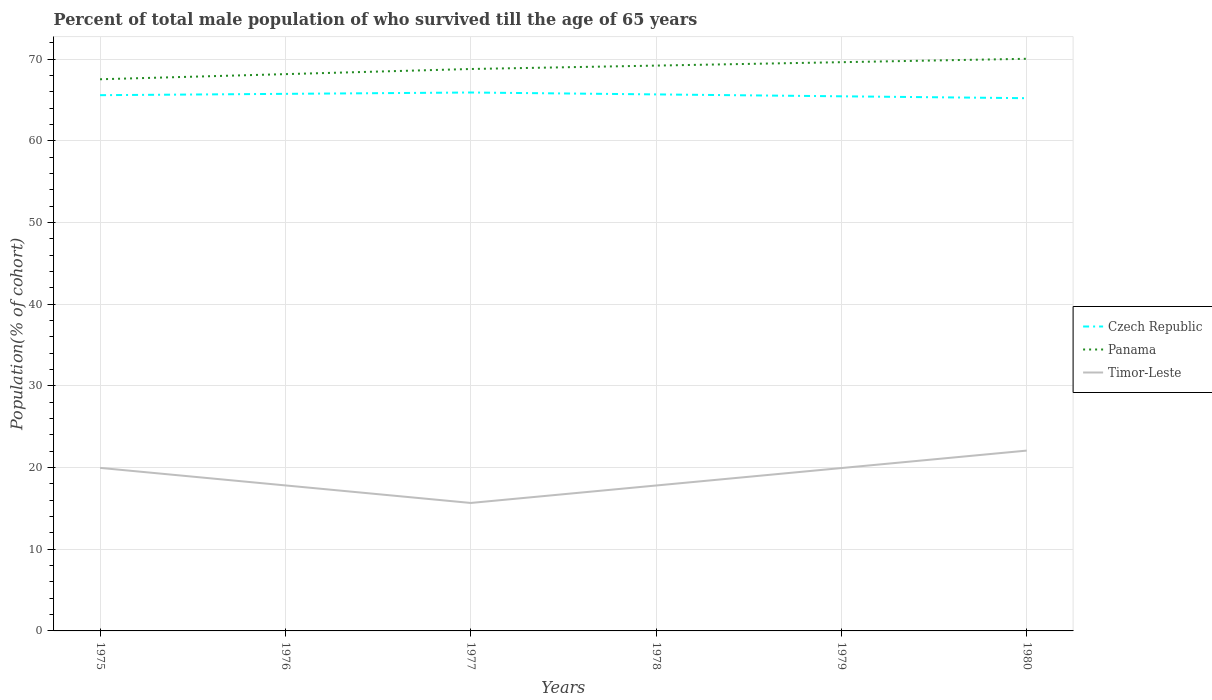How many different coloured lines are there?
Provide a succinct answer. 3. Does the line corresponding to Czech Republic intersect with the line corresponding to Panama?
Make the answer very short. No. Is the number of lines equal to the number of legend labels?
Offer a very short reply. Yes. Across all years, what is the maximum percentage of total male population who survived till the age of 65 years in Panama?
Ensure brevity in your answer.  67.56. In which year was the percentage of total male population who survived till the age of 65 years in Czech Republic maximum?
Keep it short and to the point. 1980. What is the total percentage of total male population who survived till the age of 65 years in Panama in the graph?
Your answer should be compact. -0.63. What is the difference between the highest and the second highest percentage of total male population who survived till the age of 65 years in Panama?
Provide a short and direct response. 2.51. What is the difference between the highest and the lowest percentage of total male population who survived till the age of 65 years in Panama?
Offer a very short reply. 3. Is the percentage of total male population who survived till the age of 65 years in Czech Republic strictly greater than the percentage of total male population who survived till the age of 65 years in Timor-Leste over the years?
Offer a very short reply. No. How many lines are there?
Your response must be concise. 3. How many years are there in the graph?
Ensure brevity in your answer.  6. What is the difference between two consecutive major ticks on the Y-axis?
Give a very brief answer. 10. Are the values on the major ticks of Y-axis written in scientific E-notation?
Make the answer very short. No. What is the title of the graph?
Offer a very short reply. Percent of total male population of who survived till the age of 65 years. What is the label or title of the X-axis?
Provide a short and direct response. Years. What is the label or title of the Y-axis?
Your response must be concise. Population(% of cohort). What is the Population(% of cohort) in Czech Republic in 1975?
Your response must be concise. 65.61. What is the Population(% of cohort) of Panama in 1975?
Offer a terse response. 67.56. What is the Population(% of cohort) in Timor-Leste in 1975?
Offer a very short reply. 19.97. What is the Population(% of cohort) in Czech Republic in 1976?
Provide a succinct answer. 65.77. What is the Population(% of cohort) in Panama in 1976?
Offer a terse response. 68.18. What is the Population(% of cohort) in Timor-Leste in 1976?
Offer a very short reply. 17.82. What is the Population(% of cohort) of Czech Republic in 1977?
Offer a terse response. 65.93. What is the Population(% of cohort) in Panama in 1977?
Your response must be concise. 68.81. What is the Population(% of cohort) in Timor-Leste in 1977?
Give a very brief answer. 15.67. What is the Population(% of cohort) in Czech Republic in 1978?
Your answer should be very brief. 65.7. What is the Population(% of cohort) of Panama in 1978?
Make the answer very short. 69.23. What is the Population(% of cohort) in Timor-Leste in 1978?
Ensure brevity in your answer.  17.81. What is the Population(% of cohort) of Czech Republic in 1979?
Provide a succinct answer. 65.47. What is the Population(% of cohort) of Panama in 1979?
Your response must be concise. 69.65. What is the Population(% of cohort) in Timor-Leste in 1979?
Your answer should be compact. 19.95. What is the Population(% of cohort) of Czech Republic in 1980?
Make the answer very short. 65.24. What is the Population(% of cohort) in Panama in 1980?
Your answer should be compact. 70.06. What is the Population(% of cohort) in Timor-Leste in 1980?
Make the answer very short. 22.08. Across all years, what is the maximum Population(% of cohort) of Czech Republic?
Your answer should be compact. 65.93. Across all years, what is the maximum Population(% of cohort) of Panama?
Your answer should be very brief. 70.06. Across all years, what is the maximum Population(% of cohort) of Timor-Leste?
Your response must be concise. 22.08. Across all years, what is the minimum Population(% of cohort) in Czech Republic?
Your answer should be compact. 65.24. Across all years, what is the minimum Population(% of cohort) of Panama?
Your response must be concise. 67.56. Across all years, what is the minimum Population(% of cohort) of Timor-Leste?
Keep it short and to the point. 15.67. What is the total Population(% of cohort) of Czech Republic in the graph?
Make the answer very short. 393.72. What is the total Population(% of cohort) of Panama in the graph?
Give a very brief answer. 413.49. What is the total Population(% of cohort) of Timor-Leste in the graph?
Give a very brief answer. 113.29. What is the difference between the Population(% of cohort) of Czech Republic in 1975 and that in 1976?
Ensure brevity in your answer.  -0.16. What is the difference between the Population(% of cohort) of Panama in 1975 and that in 1976?
Your answer should be very brief. -0.63. What is the difference between the Population(% of cohort) in Timor-Leste in 1975 and that in 1976?
Offer a terse response. 2.15. What is the difference between the Population(% of cohort) in Czech Republic in 1975 and that in 1977?
Keep it short and to the point. -0.33. What is the difference between the Population(% of cohort) in Panama in 1975 and that in 1977?
Offer a terse response. -1.26. What is the difference between the Population(% of cohort) in Timor-Leste in 1975 and that in 1977?
Give a very brief answer. 4.29. What is the difference between the Population(% of cohort) of Czech Republic in 1975 and that in 1978?
Offer a terse response. -0.1. What is the difference between the Population(% of cohort) in Panama in 1975 and that in 1978?
Provide a short and direct response. -1.67. What is the difference between the Population(% of cohort) of Timor-Leste in 1975 and that in 1978?
Your answer should be very brief. 2.16. What is the difference between the Population(% of cohort) in Czech Republic in 1975 and that in 1979?
Offer a very short reply. 0.14. What is the difference between the Population(% of cohort) of Panama in 1975 and that in 1979?
Offer a terse response. -2.09. What is the difference between the Population(% of cohort) of Timor-Leste in 1975 and that in 1979?
Provide a short and direct response. 0.02. What is the difference between the Population(% of cohort) of Czech Republic in 1975 and that in 1980?
Offer a very short reply. 0.37. What is the difference between the Population(% of cohort) of Panama in 1975 and that in 1980?
Keep it short and to the point. -2.51. What is the difference between the Population(% of cohort) in Timor-Leste in 1975 and that in 1980?
Provide a succinct answer. -2.12. What is the difference between the Population(% of cohort) of Czech Republic in 1976 and that in 1977?
Your answer should be very brief. -0.16. What is the difference between the Population(% of cohort) in Panama in 1976 and that in 1977?
Give a very brief answer. -0.63. What is the difference between the Population(% of cohort) in Timor-Leste in 1976 and that in 1977?
Offer a terse response. 2.15. What is the difference between the Population(% of cohort) of Czech Republic in 1976 and that in 1978?
Your response must be concise. 0.07. What is the difference between the Population(% of cohort) in Panama in 1976 and that in 1978?
Provide a succinct answer. -1.05. What is the difference between the Population(% of cohort) in Timor-Leste in 1976 and that in 1978?
Give a very brief answer. 0.01. What is the difference between the Population(% of cohort) in Czech Republic in 1976 and that in 1979?
Ensure brevity in your answer.  0.3. What is the difference between the Population(% of cohort) in Panama in 1976 and that in 1979?
Give a very brief answer. -1.46. What is the difference between the Population(% of cohort) in Timor-Leste in 1976 and that in 1979?
Keep it short and to the point. -2.13. What is the difference between the Population(% of cohort) of Czech Republic in 1976 and that in 1980?
Offer a very short reply. 0.53. What is the difference between the Population(% of cohort) of Panama in 1976 and that in 1980?
Keep it short and to the point. -1.88. What is the difference between the Population(% of cohort) in Timor-Leste in 1976 and that in 1980?
Make the answer very short. -4.26. What is the difference between the Population(% of cohort) of Czech Republic in 1977 and that in 1978?
Your response must be concise. 0.23. What is the difference between the Population(% of cohort) of Panama in 1977 and that in 1978?
Offer a terse response. -0.42. What is the difference between the Population(% of cohort) in Timor-Leste in 1977 and that in 1978?
Your response must be concise. -2.14. What is the difference between the Population(% of cohort) of Czech Republic in 1977 and that in 1979?
Ensure brevity in your answer.  0.46. What is the difference between the Population(% of cohort) in Panama in 1977 and that in 1979?
Offer a terse response. -0.83. What is the difference between the Population(% of cohort) in Timor-Leste in 1977 and that in 1979?
Your response must be concise. -4.27. What is the difference between the Population(% of cohort) in Czech Republic in 1977 and that in 1980?
Provide a succinct answer. 0.7. What is the difference between the Population(% of cohort) of Panama in 1977 and that in 1980?
Offer a terse response. -1.25. What is the difference between the Population(% of cohort) of Timor-Leste in 1977 and that in 1980?
Ensure brevity in your answer.  -6.41. What is the difference between the Population(% of cohort) in Czech Republic in 1978 and that in 1979?
Your response must be concise. 0.23. What is the difference between the Population(% of cohort) in Panama in 1978 and that in 1979?
Provide a short and direct response. -0.42. What is the difference between the Population(% of cohort) in Timor-Leste in 1978 and that in 1979?
Offer a very short reply. -2.14. What is the difference between the Population(% of cohort) of Czech Republic in 1978 and that in 1980?
Offer a terse response. 0.46. What is the difference between the Population(% of cohort) of Panama in 1978 and that in 1980?
Make the answer very short. -0.83. What is the difference between the Population(% of cohort) in Timor-Leste in 1978 and that in 1980?
Provide a short and direct response. -4.27. What is the difference between the Population(% of cohort) of Czech Republic in 1979 and that in 1980?
Ensure brevity in your answer.  0.23. What is the difference between the Population(% of cohort) in Panama in 1979 and that in 1980?
Give a very brief answer. -0.42. What is the difference between the Population(% of cohort) in Timor-Leste in 1979 and that in 1980?
Your answer should be compact. -2.14. What is the difference between the Population(% of cohort) of Czech Republic in 1975 and the Population(% of cohort) of Panama in 1976?
Keep it short and to the point. -2.58. What is the difference between the Population(% of cohort) of Czech Republic in 1975 and the Population(% of cohort) of Timor-Leste in 1976?
Your answer should be compact. 47.79. What is the difference between the Population(% of cohort) of Panama in 1975 and the Population(% of cohort) of Timor-Leste in 1976?
Ensure brevity in your answer.  49.74. What is the difference between the Population(% of cohort) in Czech Republic in 1975 and the Population(% of cohort) in Panama in 1977?
Provide a short and direct response. -3.21. What is the difference between the Population(% of cohort) of Czech Republic in 1975 and the Population(% of cohort) of Timor-Leste in 1977?
Give a very brief answer. 49.94. What is the difference between the Population(% of cohort) of Panama in 1975 and the Population(% of cohort) of Timor-Leste in 1977?
Make the answer very short. 51.89. What is the difference between the Population(% of cohort) of Czech Republic in 1975 and the Population(% of cohort) of Panama in 1978?
Your response must be concise. -3.62. What is the difference between the Population(% of cohort) of Czech Republic in 1975 and the Population(% of cohort) of Timor-Leste in 1978?
Provide a succinct answer. 47.8. What is the difference between the Population(% of cohort) in Panama in 1975 and the Population(% of cohort) in Timor-Leste in 1978?
Offer a terse response. 49.75. What is the difference between the Population(% of cohort) of Czech Republic in 1975 and the Population(% of cohort) of Panama in 1979?
Offer a terse response. -4.04. What is the difference between the Population(% of cohort) in Czech Republic in 1975 and the Population(% of cohort) in Timor-Leste in 1979?
Ensure brevity in your answer.  45.66. What is the difference between the Population(% of cohort) in Panama in 1975 and the Population(% of cohort) in Timor-Leste in 1979?
Offer a very short reply. 47.61. What is the difference between the Population(% of cohort) in Czech Republic in 1975 and the Population(% of cohort) in Panama in 1980?
Offer a terse response. -4.46. What is the difference between the Population(% of cohort) of Czech Republic in 1975 and the Population(% of cohort) of Timor-Leste in 1980?
Provide a short and direct response. 43.52. What is the difference between the Population(% of cohort) of Panama in 1975 and the Population(% of cohort) of Timor-Leste in 1980?
Provide a succinct answer. 45.47. What is the difference between the Population(% of cohort) in Czech Republic in 1976 and the Population(% of cohort) in Panama in 1977?
Provide a succinct answer. -3.04. What is the difference between the Population(% of cohort) in Czech Republic in 1976 and the Population(% of cohort) in Timor-Leste in 1977?
Your answer should be very brief. 50.1. What is the difference between the Population(% of cohort) of Panama in 1976 and the Population(% of cohort) of Timor-Leste in 1977?
Make the answer very short. 52.51. What is the difference between the Population(% of cohort) of Czech Republic in 1976 and the Population(% of cohort) of Panama in 1978?
Your answer should be compact. -3.46. What is the difference between the Population(% of cohort) of Czech Republic in 1976 and the Population(% of cohort) of Timor-Leste in 1978?
Ensure brevity in your answer.  47.96. What is the difference between the Population(% of cohort) of Panama in 1976 and the Population(% of cohort) of Timor-Leste in 1978?
Ensure brevity in your answer.  50.38. What is the difference between the Population(% of cohort) of Czech Republic in 1976 and the Population(% of cohort) of Panama in 1979?
Offer a very short reply. -3.88. What is the difference between the Population(% of cohort) of Czech Republic in 1976 and the Population(% of cohort) of Timor-Leste in 1979?
Ensure brevity in your answer.  45.82. What is the difference between the Population(% of cohort) of Panama in 1976 and the Population(% of cohort) of Timor-Leste in 1979?
Offer a very short reply. 48.24. What is the difference between the Population(% of cohort) in Czech Republic in 1976 and the Population(% of cohort) in Panama in 1980?
Make the answer very short. -4.29. What is the difference between the Population(% of cohort) of Czech Republic in 1976 and the Population(% of cohort) of Timor-Leste in 1980?
Provide a short and direct response. 43.69. What is the difference between the Population(% of cohort) of Panama in 1976 and the Population(% of cohort) of Timor-Leste in 1980?
Offer a terse response. 46.1. What is the difference between the Population(% of cohort) in Czech Republic in 1977 and the Population(% of cohort) in Panama in 1978?
Make the answer very short. -3.3. What is the difference between the Population(% of cohort) of Czech Republic in 1977 and the Population(% of cohort) of Timor-Leste in 1978?
Your response must be concise. 48.13. What is the difference between the Population(% of cohort) in Panama in 1977 and the Population(% of cohort) in Timor-Leste in 1978?
Give a very brief answer. 51.01. What is the difference between the Population(% of cohort) in Czech Republic in 1977 and the Population(% of cohort) in Panama in 1979?
Provide a succinct answer. -3.71. What is the difference between the Population(% of cohort) of Czech Republic in 1977 and the Population(% of cohort) of Timor-Leste in 1979?
Provide a short and direct response. 45.99. What is the difference between the Population(% of cohort) in Panama in 1977 and the Population(% of cohort) in Timor-Leste in 1979?
Offer a terse response. 48.87. What is the difference between the Population(% of cohort) in Czech Republic in 1977 and the Population(% of cohort) in Panama in 1980?
Ensure brevity in your answer.  -4.13. What is the difference between the Population(% of cohort) in Czech Republic in 1977 and the Population(% of cohort) in Timor-Leste in 1980?
Your answer should be very brief. 43.85. What is the difference between the Population(% of cohort) in Panama in 1977 and the Population(% of cohort) in Timor-Leste in 1980?
Give a very brief answer. 46.73. What is the difference between the Population(% of cohort) of Czech Republic in 1978 and the Population(% of cohort) of Panama in 1979?
Keep it short and to the point. -3.95. What is the difference between the Population(% of cohort) in Czech Republic in 1978 and the Population(% of cohort) in Timor-Leste in 1979?
Keep it short and to the point. 45.76. What is the difference between the Population(% of cohort) of Panama in 1978 and the Population(% of cohort) of Timor-Leste in 1979?
Offer a very short reply. 49.28. What is the difference between the Population(% of cohort) in Czech Republic in 1978 and the Population(% of cohort) in Panama in 1980?
Keep it short and to the point. -4.36. What is the difference between the Population(% of cohort) of Czech Republic in 1978 and the Population(% of cohort) of Timor-Leste in 1980?
Your answer should be compact. 43.62. What is the difference between the Population(% of cohort) of Panama in 1978 and the Population(% of cohort) of Timor-Leste in 1980?
Provide a succinct answer. 47.15. What is the difference between the Population(% of cohort) in Czech Republic in 1979 and the Population(% of cohort) in Panama in 1980?
Keep it short and to the point. -4.59. What is the difference between the Population(% of cohort) of Czech Republic in 1979 and the Population(% of cohort) of Timor-Leste in 1980?
Keep it short and to the point. 43.39. What is the difference between the Population(% of cohort) of Panama in 1979 and the Population(% of cohort) of Timor-Leste in 1980?
Provide a succinct answer. 47.56. What is the average Population(% of cohort) of Czech Republic per year?
Give a very brief answer. 65.62. What is the average Population(% of cohort) in Panama per year?
Offer a very short reply. 68.92. What is the average Population(% of cohort) of Timor-Leste per year?
Your response must be concise. 18.88. In the year 1975, what is the difference between the Population(% of cohort) of Czech Republic and Population(% of cohort) of Panama?
Give a very brief answer. -1.95. In the year 1975, what is the difference between the Population(% of cohort) of Czech Republic and Population(% of cohort) of Timor-Leste?
Your response must be concise. 45.64. In the year 1975, what is the difference between the Population(% of cohort) of Panama and Population(% of cohort) of Timor-Leste?
Offer a very short reply. 47.59. In the year 1976, what is the difference between the Population(% of cohort) in Czech Republic and Population(% of cohort) in Panama?
Make the answer very short. -2.41. In the year 1976, what is the difference between the Population(% of cohort) in Czech Republic and Population(% of cohort) in Timor-Leste?
Ensure brevity in your answer.  47.95. In the year 1976, what is the difference between the Population(% of cohort) in Panama and Population(% of cohort) in Timor-Leste?
Your answer should be very brief. 50.37. In the year 1977, what is the difference between the Population(% of cohort) in Czech Republic and Population(% of cohort) in Panama?
Offer a very short reply. -2.88. In the year 1977, what is the difference between the Population(% of cohort) in Czech Republic and Population(% of cohort) in Timor-Leste?
Your response must be concise. 50.26. In the year 1977, what is the difference between the Population(% of cohort) of Panama and Population(% of cohort) of Timor-Leste?
Give a very brief answer. 53.14. In the year 1978, what is the difference between the Population(% of cohort) of Czech Republic and Population(% of cohort) of Panama?
Keep it short and to the point. -3.53. In the year 1978, what is the difference between the Population(% of cohort) of Czech Republic and Population(% of cohort) of Timor-Leste?
Ensure brevity in your answer.  47.89. In the year 1978, what is the difference between the Population(% of cohort) of Panama and Population(% of cohort) of Timor-Leste?
Your response must be concise. 51.42. In the year 1979, what is the difference between the Population(% of cohort) in Czech Republic and Population(% of cohort) in Panama?
Your response must be concise. -4.18. In the year 1979, what is the difference between the Population(% of cohort) in Czech Republic and Population(% of cohort) in Timor-Leste?
Your response must be concise. 45.52. In the year 1979, what is the difference between the Population(% of cohort) of Panama and Population(% of cohort) of Timor-Leste?
Keep it short and to the point. 49.7. In the year 1980, what is the difference between the Population(% of cohort) of Czech Republic and Population(% of cohort) of Panama?
Ensure brevity in your answer.  -4.83. In the year 1980, what is the difference between the Population(% of cohort) of Czech Republic and Population(% of cohort) of Timor-Leste?
Make the answer very short. 43.15. In the year 1980, what is the difference between the Population(% of cohort) of Panama and Population(% of cohort) of Timor-Leste?
Offer a terse response. 47.98. What is the ratio of the Population(% of cohort) in Panama in 1975 to that in 1976?
Provide a short and direct response. 0.99. What is the ratio of the Population(% of cohort) of Timor-Leste in 1975 to that in 1976?
Your answer should be compact. 1.12. What is the ratio of the Population(% of cohort) in Panama in 1975 to that in 1977?
Your response must be concise. 0.98. What is the ratio of the Population(% of cohort) of Timor-Leste in 1975 to that in 1977?
Provide a short and direct response. 1.27. What is the ratio of the Population(% of cohort) of Panama in 1975 to that in 1978?
Your answer should be very brief. 0.98. What is the ratio of the Population(% of cohort) in Timor-Leste in 1975 to that in 1978?
Your answer should be compact. 1.12. What is the ratio of the Population(% of cohort) in Timor-Leste in 1975 to that in 1979?
Your answer should be compact. 1. What is the ratio of the Population(% of cohort) in Panama in 1975 to that in 1980?
Offer a terse response. 0.96. What is the ratio of the Population(% of cohort) in Timor-Leste in 1975 to that in 1980?
Offer a very short reply. 0.9. What is the ratio of the Population(% of cohort) in Czech Republic in 1976 to that in 1977?
Offer a very short reply. 1. What is the ratio of the Population(% of cohort) of Panama in 1976 to that in 1977?
Ensure brevity in your answer.  0.99. What is the ratio of the Population(% of cohort) of Timor-Leste in 1976 to that in 1977?
Your answer should be compact. 1.14. What is the ratio of the Population(% of cohort) in Panama in 1976 to that in 1978?
Give a very brief answer. 0.98. What is the ratio of the Population(% of cohort) of Czech Republic in 1976 to that in 1979?
Ensure brevity in your answer.  1. What is the ratio of the Population(% of cohort) of Panama in 1976 to that in 1979?
Give a very brief answer. 0.98. What is the ratio of the Population(% of cohort) of Timor-Leste in 1976 to that in 1979?
Offer a terse response. 0.89. What is the ratio of the Population(% of cohort) in Czech Republic in 1976 to that in 1980?
Provide a succinct answer. 1.01. What is the ratio of the Population(% of cohort) of Panama in 1976 to that in 1980?
Offer a very short reply. 0.97. What is the ratio of the Population(% of cohort) in Timor-Leste in 1976 to that in 1980?
Provide a succinct answer. 0.81. What is the ratio of the Population(% of cohort) in Czech Republic in 1977 to that in 1979?
Keep it short and to the point. 1.01. What is the ratio of the Population(% of cohort) in Panama in 1977 to that in 1979?
Your response must be concise. 0.99. What is the ratio of the Population(% of cohort) of Timor-Leste in 1977 to that in 1979?
Ensure brevity in your answer.  0.79. What is the ratio of the Population(% of cohort) of Czech Republic in 1977 to that in 1980?
Make the answer very short. 1.01. What is the ratio of the Population(% of cohort) of Panama in 1977 to that in 1980?
Ensure brevity in your answer.  0.98. What is the ratio of the Population(% of cohort) in Timor-Leste in 1977 to that in 1980?
Ensure brevity in your answer.  0.71. What is the ratio of the Population(% of cohort) of Czech Republic in 1978 to that in 1979?
Make the answer very short. 1. What is the ratio of the Population(% of cohort) in Timor-Leste in 1978 to that in 1979?
Offer a terse response. 0.89. What is the ratio of the Population(% of cohort) of Czech Republic in 1978 to that in 1980?
Ensure brevity in your answer.  1.01. What is the ratio of the Population(% of cohort) in Timor-Leste in 1978 to that in 1980?
Offer a terse response. 0.81. What is the ratio of the Population(% of cohort) of Czech Republic in 1979 to that in 1980?
Your answer should be compact. 1. What is the ratio of the Population(% of cohort) of Timor-Leste in 1979 to that in 1980?
Provide a short and direct response. 0.9. What is the difference between the highest and the second highest Population(% of cohort) of Czech Republic?
Offer a terse response. 0.16. What is the difference between the highest and the second highest Population(% of cohort) in Panama?
Your answer should be very brief. 0.42. What is the difference between the highest and the second highest Population(% of cohort) of Timor-Leste?
Make the answer very short. 2.12. What is the difference between the highest and the lowest Population(% of cohort) in Czech Republic?
Offer a very short reply. 0.7. What is the difference between the highest and the lowest Population(% of cohort) in Panama?
Give a very brief answer. 2.51. What is the difference between the highest and the lowest Population(% of cohort) in Timor-Leste?
Make the answer very short. 6.41. 